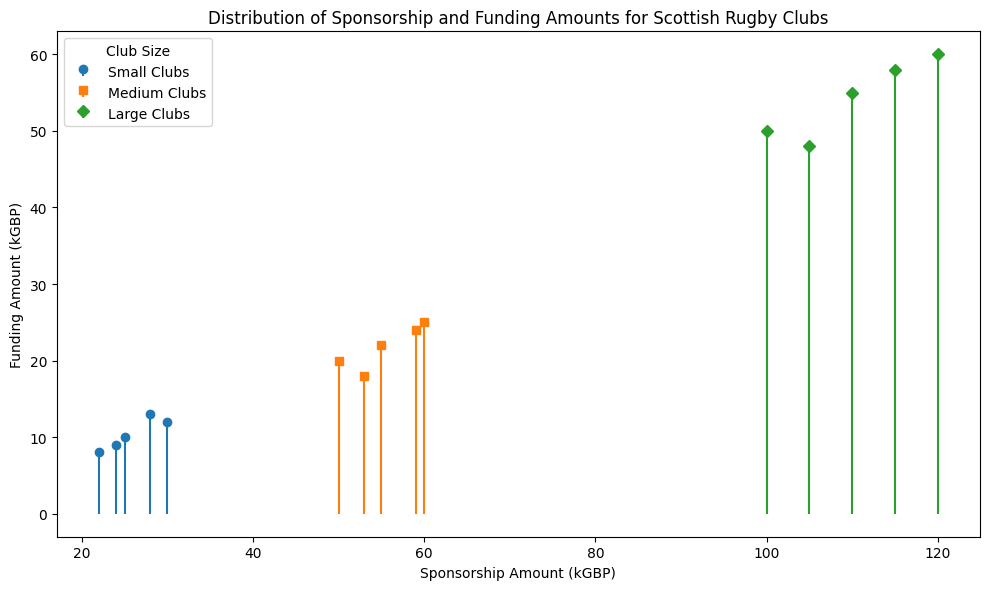what is the average sponsorship amount for medium clubs? Gather all the sponsorship amounts for medium clubs: 50, 55, 60, 53, 59. Sum these values up (50 + 55 + 60 + 53 + 59 = 277) and divide by the number of data points (277 / 5 = 55.4)
Answer: 55.4 Which club size has the highest sponsorship amount? Observe the highest values in the plot for each club size. Small clubs have a maximum of 30 kGBP, medium clubs have a maximum of 60 kGBP, and large clubs have a maximum of 120 kGBP. The largest value is 120 kGBP for large clubs.
Answer: Large clubs How does the funding amount for small clubs compare to that of large clubs? Compare the range of funding amounts for both sizes. Small clubs range from 8 to 13 kGBP, and large clubs range from 48 to 60 kGBP. Large clubs receive significantly more funding.
Answer: Large clubs receive more funding What is the total funding amount of all small clubs? Sum the funding amounts for all small clubs: 10, 12, 8, 13, 9. The total is 10 + 12 + 8 + 13 + 9 = 52 kGBP.
Answer: 52 kGBP Are there more data points for medium clubs or small clubs? Count the number of data points for each club size. There are 5 data points for both small and medium clubs.
Answer: Equal What is the difference in maximum sponsorship amounts between medium and large clubs? Identify the maximum sponsorship for medium clubs (60 kGBP) and for large clubs (120 kGBP). The difference is 120 - 60 = 60 kGBP
Answer: 60 kGBP What is the average funding amount for large clubs? Gather all the funding amounts for large clubs: 50, 55, 60, 48, 58. Sum these values up (50 + 55 + 60 + 48 + 58 = 271) and divide by the number of data points (271 / 5 = 54.2)
Answer: 54.2 What is the median sponsorship amount for small clubs? List the sponsorship amounts for small clubs in ascending order: 22, 24, 25, 28, 30. The median is the middle value, which is 25.
Answer: 25 kGBP Which club size has the lowest funding amount and what is it? Observe the lowest values in each club size's funding amounts. Small clubs range from 8 to 13 kGBP, so the lowest funding amount is 8 kGBP. No other club size has a lower value.
Answer: Small clubs, 8 kGBP How many large clubs have a sponsorship amount greater than 110 kGBP? List sponsorship amounts for large clubs: 100, 110, 120, 105, 115. Only 120 and 115 are greater than 110. Thus, the number of large clubs is 2.
Answer: 2 